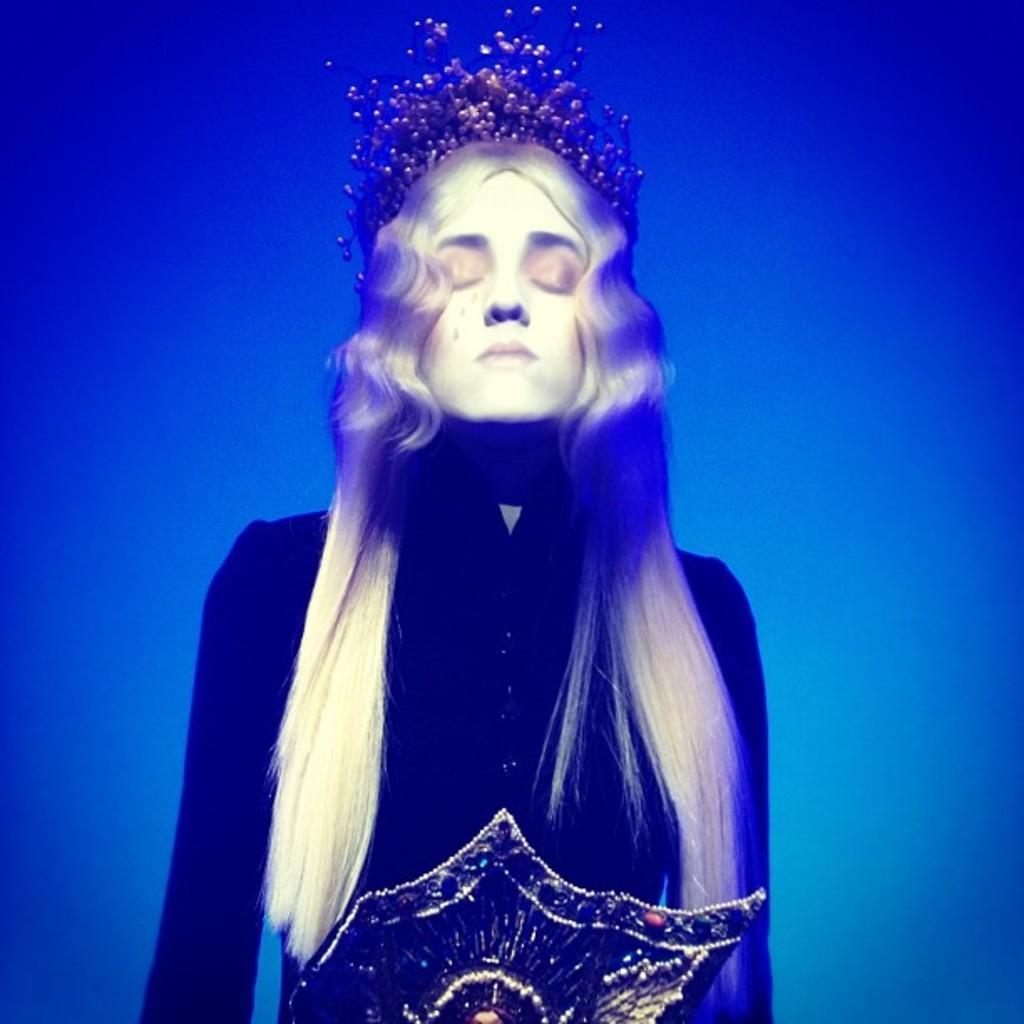Please provide a concise description of this image. In this image I can see the person inside the water. The water are in blue color and I can see the person wearing the dress. 